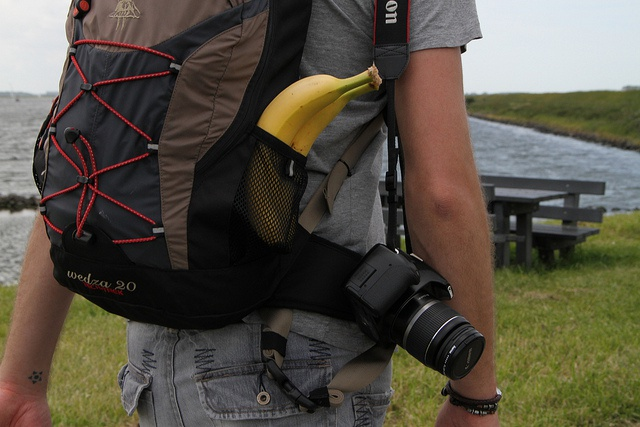Describe the objects in this image and their specific colors. I can see people in black, white, gray, and maroon tones, backpack in white, black, gray, and maroon tones, banana in white, olive, black, and tan tones, bench in white, black, and gray tones, and people in white, black, and gray tones in this image. 